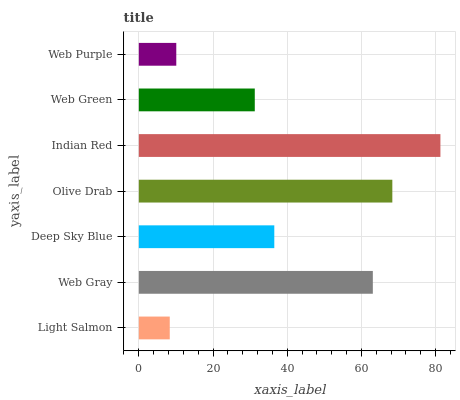Is Light Salmon the minimum?
Answer yes or no. Yes. Is Indian Red the maximum?
Answer yes or no. Yes. Is Web Gray the minimum?
Answer yes or no. No. Is Web Gray the maximum?
Answer yes or no. No. Is Web Gray greater than Light Salmon?
Answer yes or no. Yes. Is Light Salmon less than Web Gray?
Answer yes or no. Yes. Is Light Salmon greater than Web Gray?
Answer yes or no. No. Is Web Gray less than Light Salmon?
Answer yes or no. No. Is Deep Sky Blue the high median?
Answer yes or no. Yes. Is Deep Sky Blue the low median?
Answer yes or no. Yes. Is Web Green the high median?
Answer yes or no. No. Is Web Green the low median?
Answer yes or no. No. 